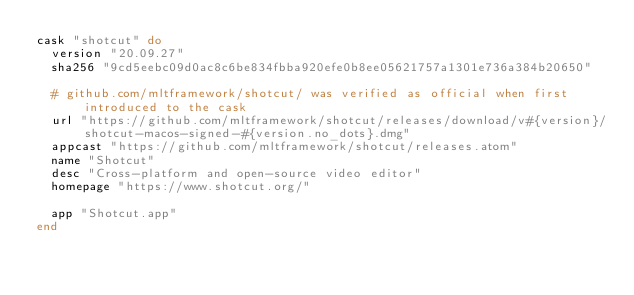Convert code to text. <code><loc_0><loc_0><loc_500><loc_500><_Ruby_>cask "shotcut" do
  version "20.09.27"
  sha256 "9cd5eebc09d0ac8c6be834fbba920efe0b8ee05621757a1301e736a384b20650"

  # github.com/mltframework/shotcut/ was verified as official when first introduced to the cask
  url "https://github.com/mltframework/shotcut/releases/download/v#{version}/shotcut-macos-signed-#{version.no_dots}.dmg"
  appcast "https://github.com/mltframework/shotcut/releases.atom"
  name "Shotcut"
  desc "Cross-platform and open-source video editor"
  homepage "https://www.shotcut.org/"

  app "Shotcut.app"
end
</code> 